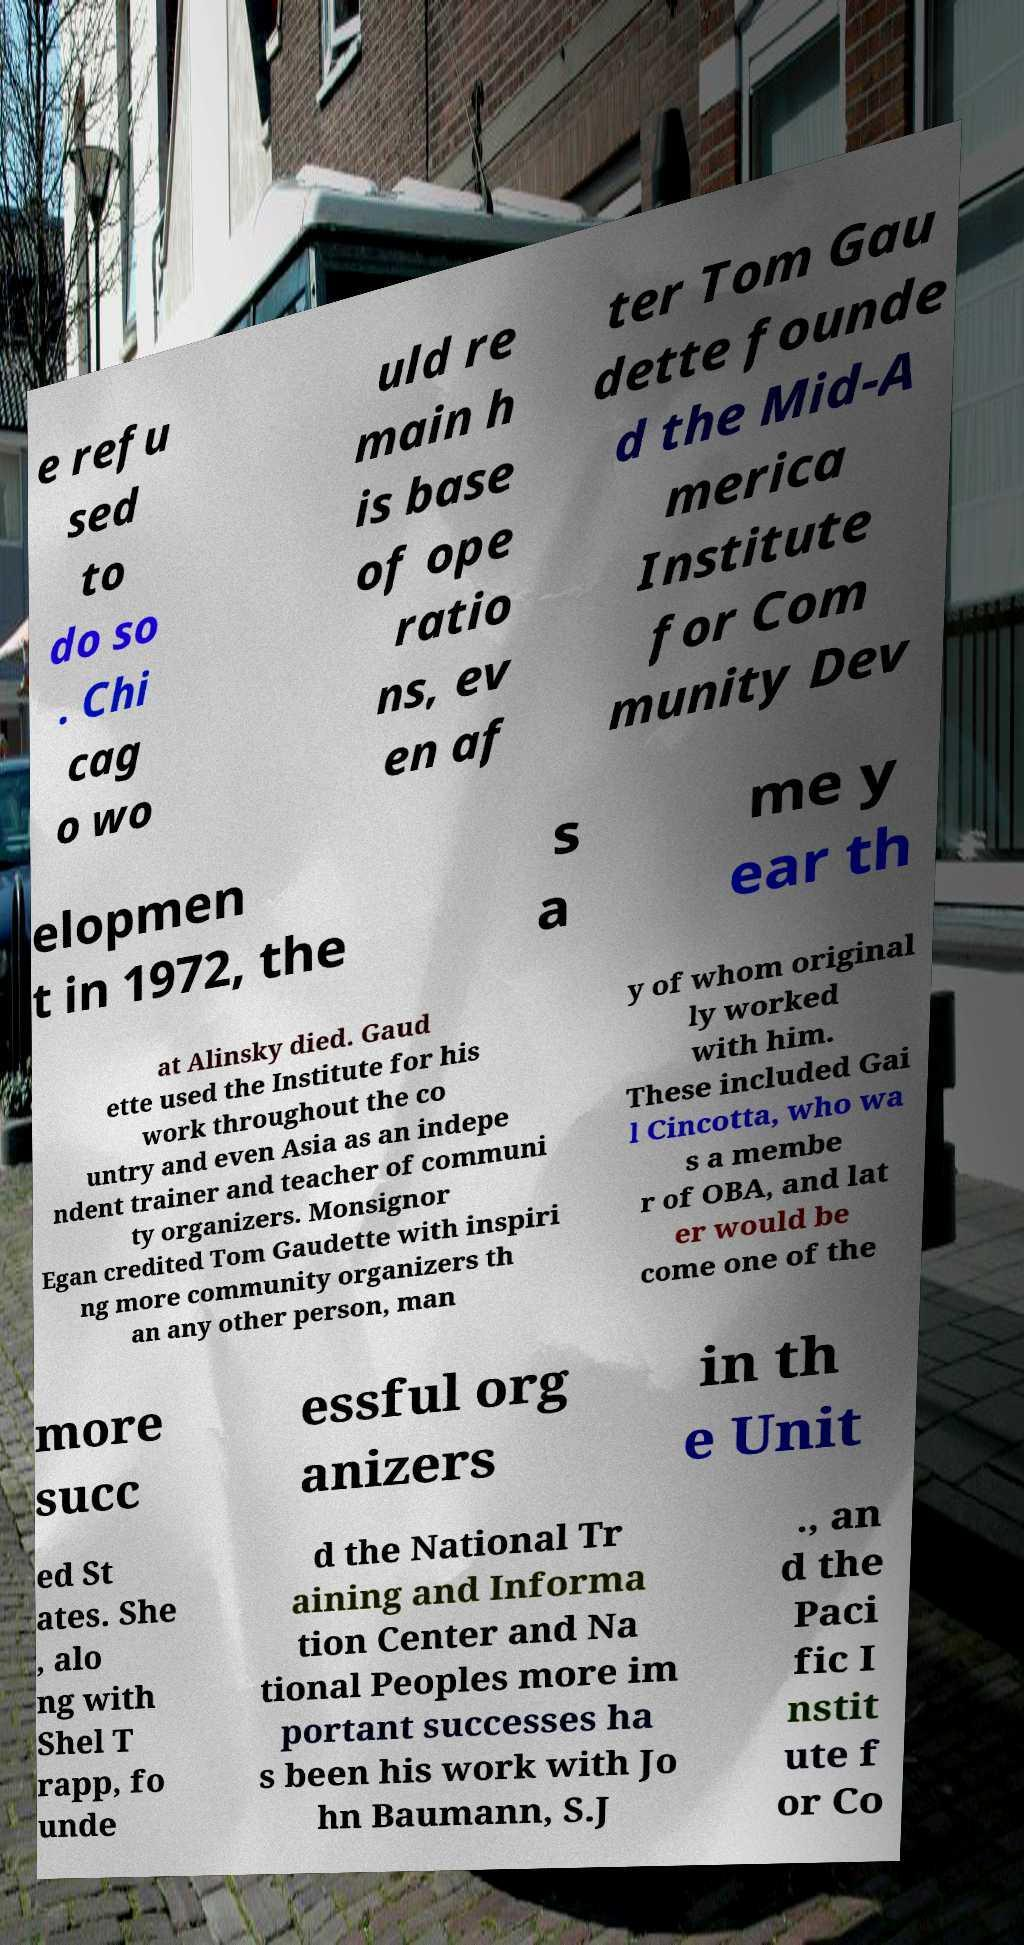Could you extract and type out the text from this image? e refu sed to do so . Chi cag o wo uld re main h is base of ope ratio ns, ev en af ter Tom Gau dette founde d the Mid-A merica Institute for Com munity Dev elopmen t in 1972, the s a me y ear th at Alinsky died. Gaud ette used the Institute for his work throughout the co untry and even Asia as an indepe ndent trainer and teacher of communi ty organizers. Monsignor Egan credited Tom Gaudette with inspiri ng more community organizers th an any other person, man y of whom original ly worked with him. These included Gai l Cincotta, who wa s a membe r of OBA, and lat er would be come one of the more succ essful org anizers in th e Unit ed St ates. She , alo ng with Shel T rapp, fo unde d the National Tr aining and Informa tion Center and Na tional Peoples more im portant successes ha s been his work with Jo hn Baumann, S.J ., an d the Paci fic I nstit ute f or Co 